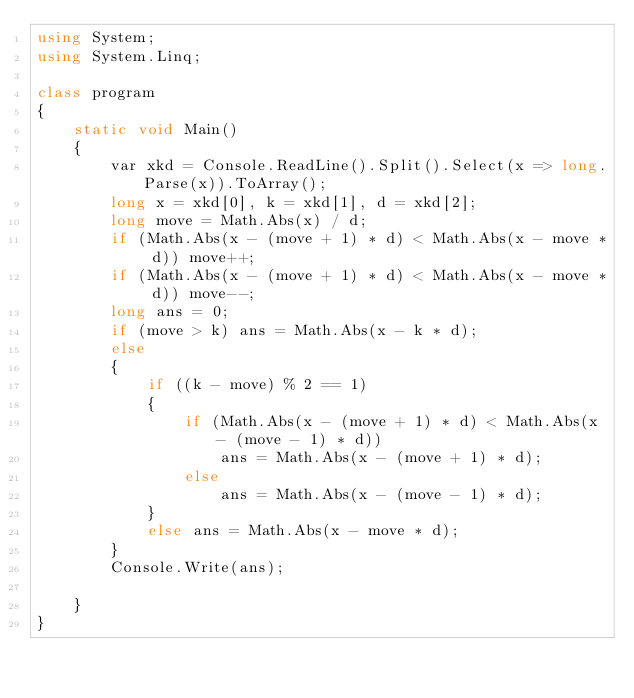Convert code to text. <code><loc_0><loc_0><loc_500><loc_500><_C#_>using System;
using System.Linq;

class program
{
    static void Main()
    {
        var xkd = Console.ReadLine().Split().Select(x => long.Parse(x)).ToArray();
        long x = xkd[0], k = xkd[1], d = xkd[2];
        long move = Math.Abs(x) / d;
        if (Math.Abs(x - (move + 1) * d) < Math.Abs(x - move * d)) move++;
        if (Math.Abs(x - (move + 1) * d) < Math.Abs(x - move * d)) move--;
        long ans = 0;
        if (move > k) ans = Math.Abs(x - k * d);
        else
        {
            if ((k - move) % 2 == 1)
            {
                if (Math.Abs(x - (move + 1) * d) < Math.Abs(x - (move - 1) * d))
                    ans = Math.Abs(x - (move + 1) * d);
                else
                    ans = Math.Abs(x - (move - 1) * d);
            }
            else ans = Math.Abs(x - move * d);
        }
        Console.Write(ans);

    }
}
</code> 